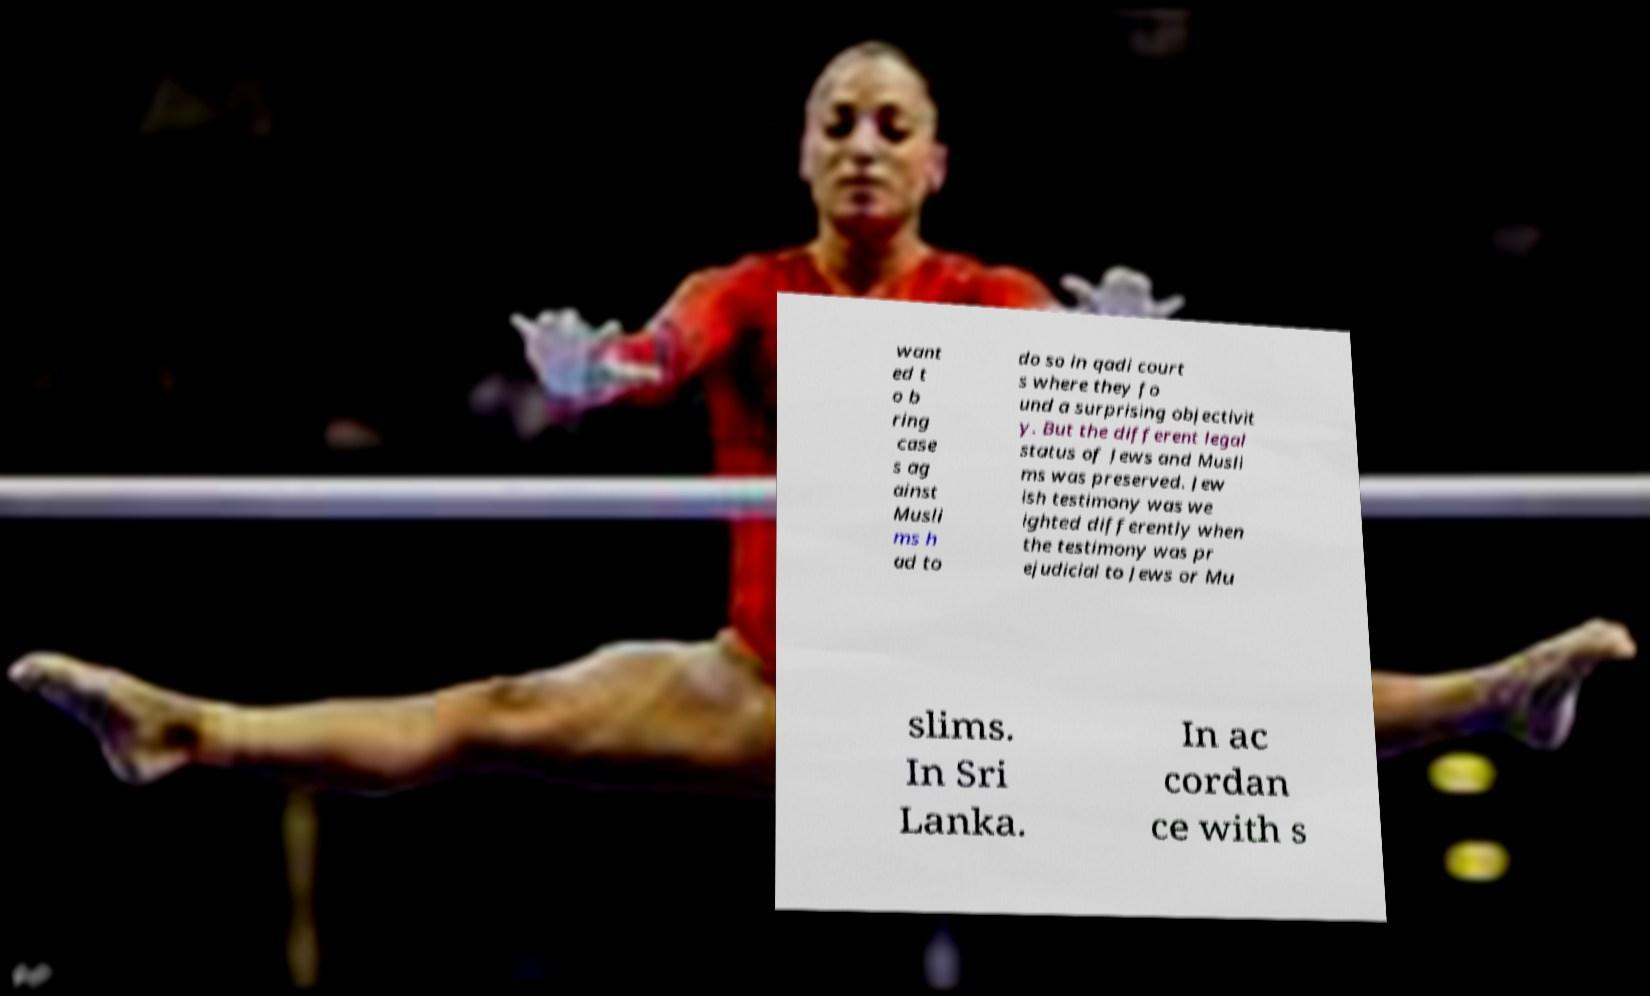I need the written content from this picture converted into text. Can you do that? want ed t o b ring case s ag ainst Musli ms h ad to do so in qadi court s where they fo und a surprising objectivit y. But the different legal status of Jews and Musli ms was preserved. Jew ish testimony was we ighted differently when the testimony was pr ejudicial to Jews or Mu slims. In Sri Lanka. In ac cordan ce with s 